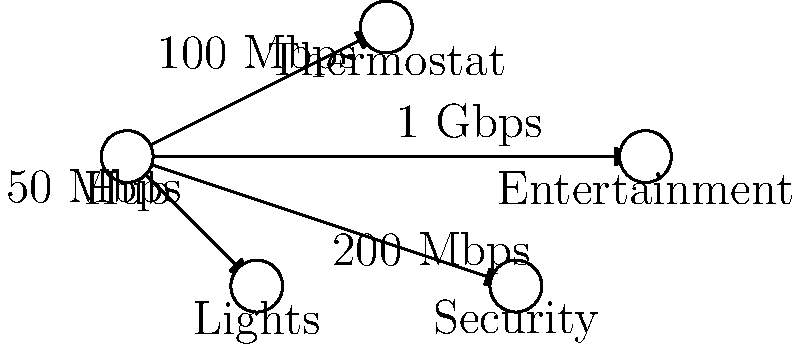Based on the smart home automation network diagram, which device has the highest bandwidth connection to the central hub, and what is its connection speed? To answer this question, we need to analyze the network diagram and compare the connection speeds between the central hub and each connected device. Let's examine each connection:

1. Hub to Thermostat: 100 Mbps
2. Hub to Lights: 50 Mbps
3. Hub to Security: 200 Mbps
4. Hub to Entertainment: 1 Gbps

To compare these speeds, we need to convert them to the same unit. Let's convert all speeds to Mbps:

1. 100 Mbps = 100 Mbps
2. 50 Mbps = 50 Mbps
3. 200 Mbps = 200 Mbps
4. 1 Gbps = 1000 Mbps (since 1 Gbps = 1000 Mbps)

Comparing these values, we can see that the Entertainment system has the highest bandwidth connection at 1000 Mbps or 1 Gbps.
Answer: Entertainment system, 1 Gbps 